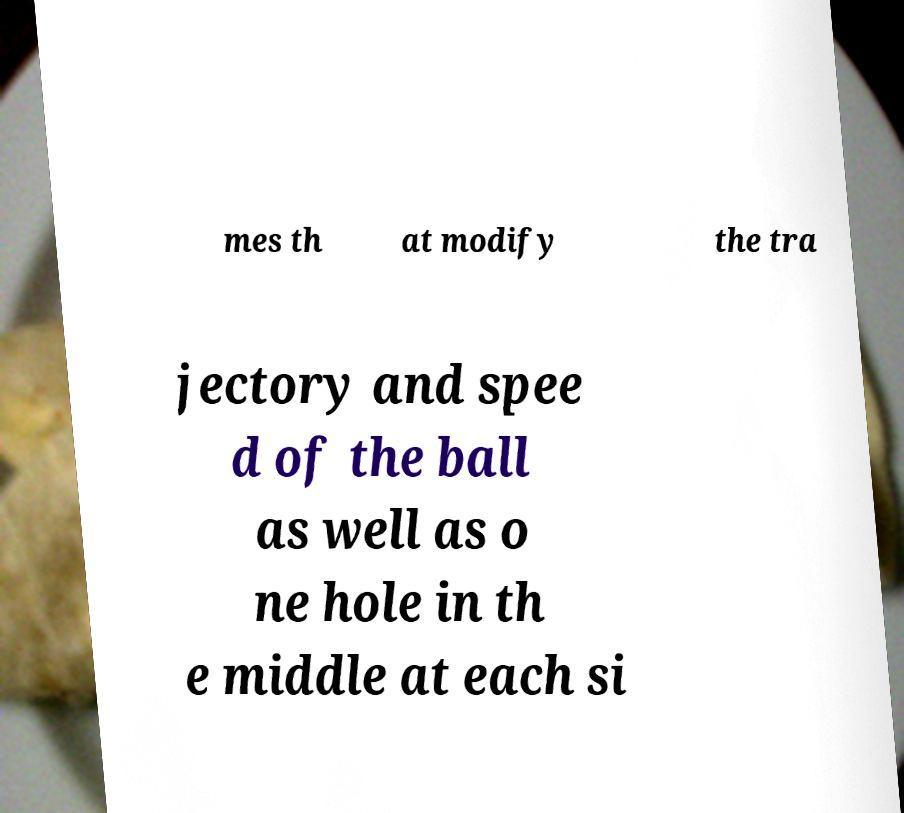Could you assist in decoding the text presented in this image and type it out clearly? mes th at modify the tra jectory and spee d of the ball as well as o ne hole in th e middle at each si 